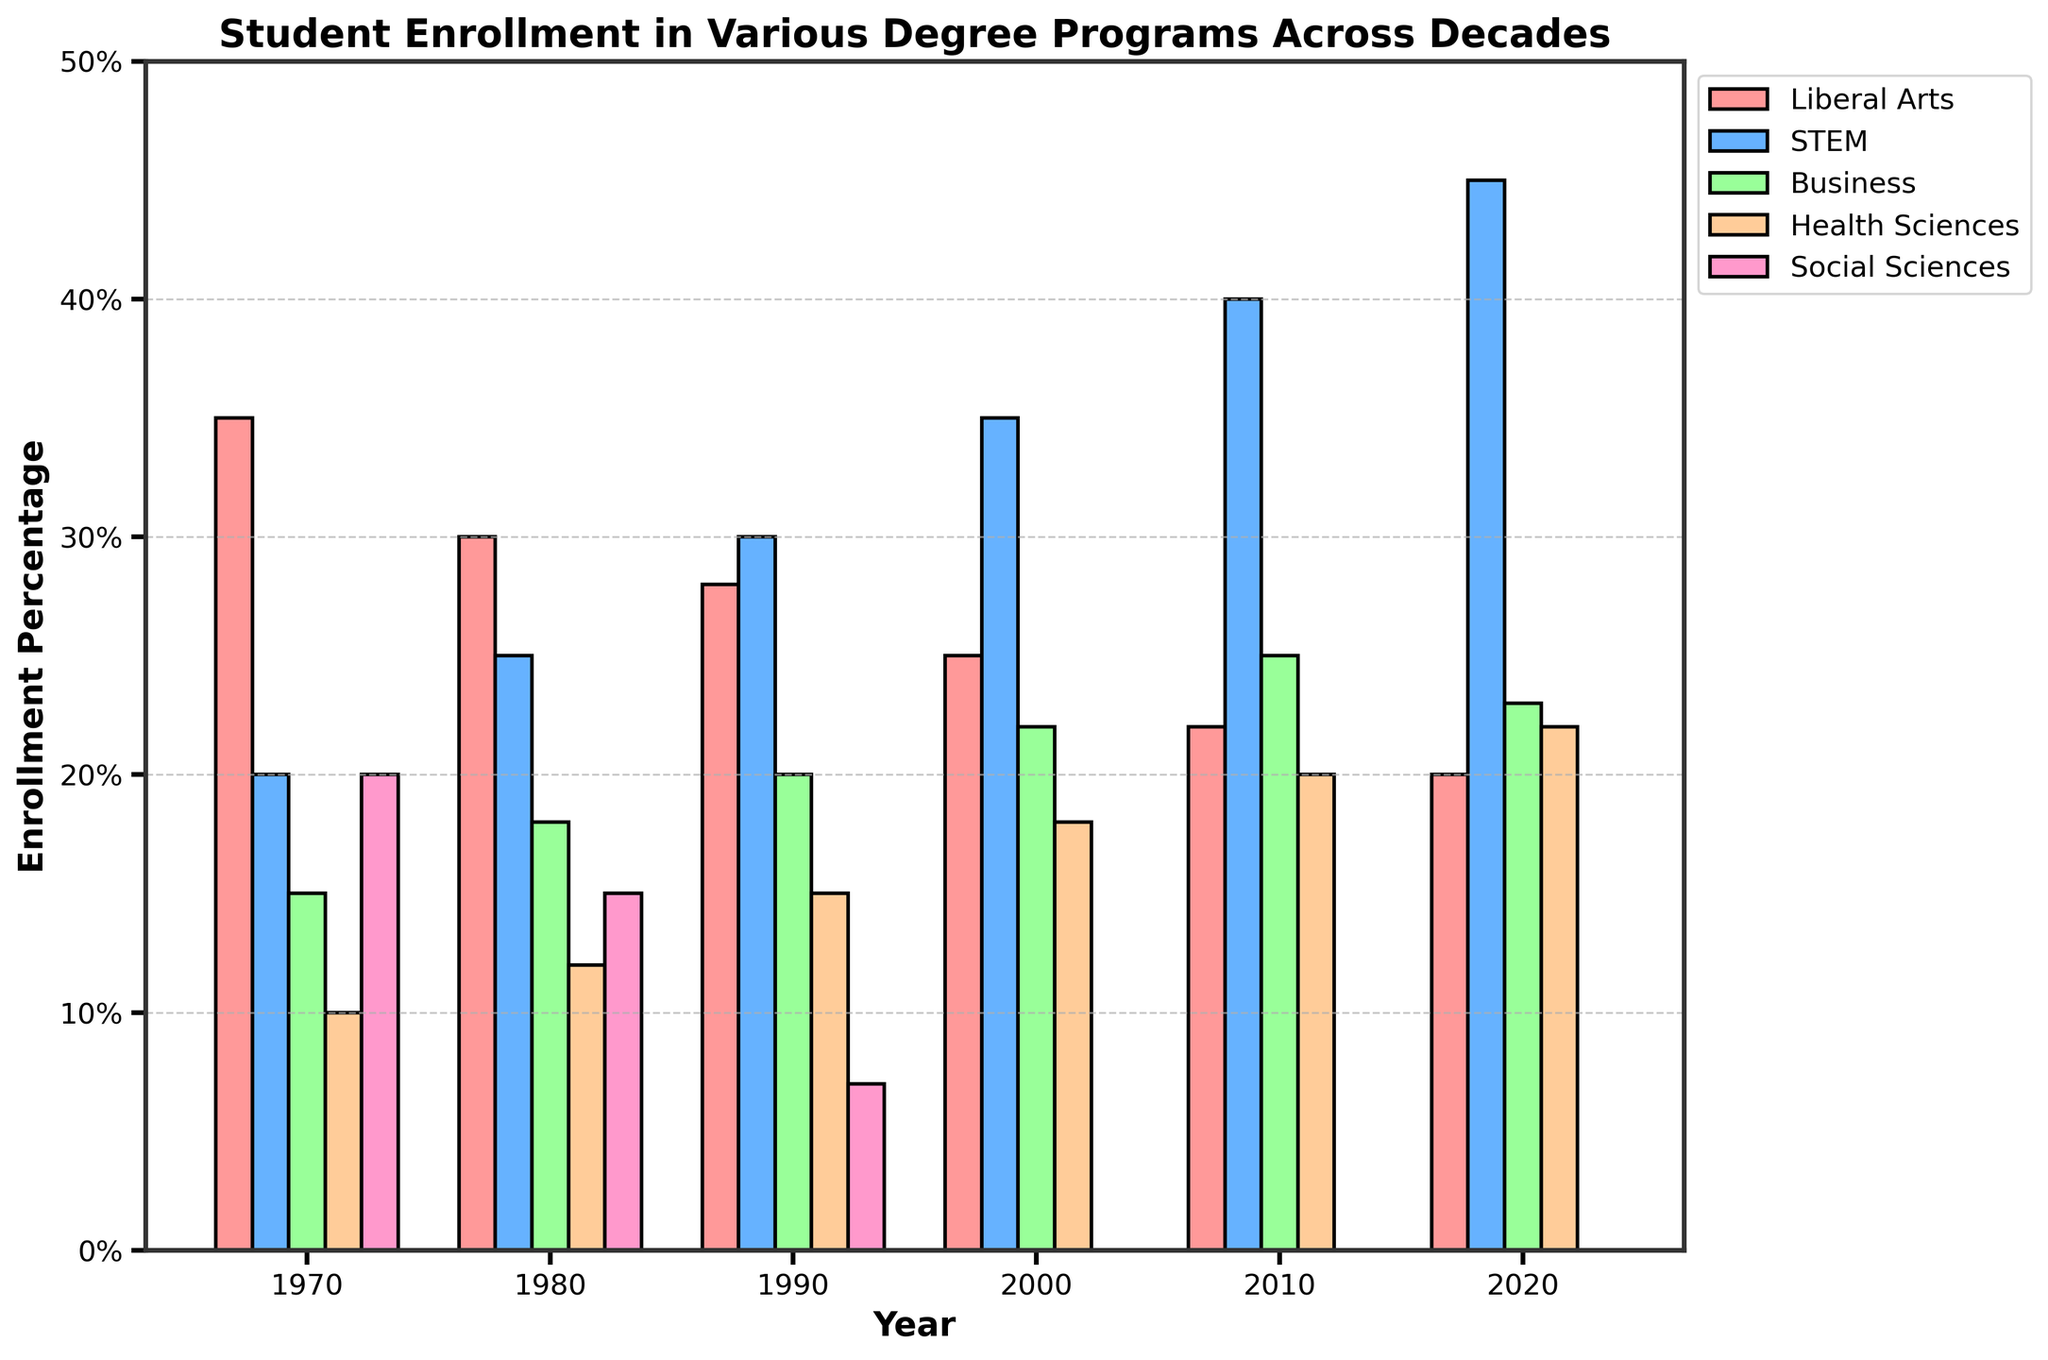What are the two most popular degree programs in 2020? The heights of the bars in 2020 show the enrollment percentages. STEM and Health Sciences have the highest enrollments.
Answer: STEM and Health Sciences How has enrollment in Liberal Arts changed from 1970 to 2020? By comparing the height of the bars, it's evident that enrollment dropped from 35% in 1970 to 20% in 2020.
Answer: Dropped by 15% In which decade did STEM surpass Liberal Arts in enrollment percentage? By checking when the STEM bar's height exceeded the Liberal Arts bar's height, it happened in the 1980s.
Answer: 1980s Which degree program experienced the most consistent enrollment over these decades? Examining the bars, STEM shows a consistent upward trend, while others fluctuate.
Answer: STEM By how much did Business program enrollment increase from 1970 to 2000? Comparing the heights of the bars, enrollment increased from 15% in 1970 to 22% in 2000.
Answer: Increased by 7% What is the average enrollment percentage for Health Sciences from 2000 to 2020? The average of Health Sciences' percentages for 2000, 2010, and 2020: (18 + 20 + 22)/3 = 20%.
Answer: 20% Which degree program had a complete drop in enrollment by 2000? Social Sciences had enrollments in 1970s, 1980s, and early 1990s, but dropped to 0% in 2000 continuing onward.
Answer: Social Sciences In which decade did Business program enrollment peak? The highest bar for Business is 2010 with 25%.
Answer: 2010 What is the total enrollment percentage for Liberal Arts and Social Sciences combined in 1980? Adding the values for Liberal Arts (30%) and Social Sciences (15%) in 1980 gives 45%.
Answer: 45% What trend is observed in the enrollment for Health Sciences from 1970 to 2020? The bars for Health Sciences show a steady increase from 10% in 1970 to 22% in 2020.
Answer: Steady increase 